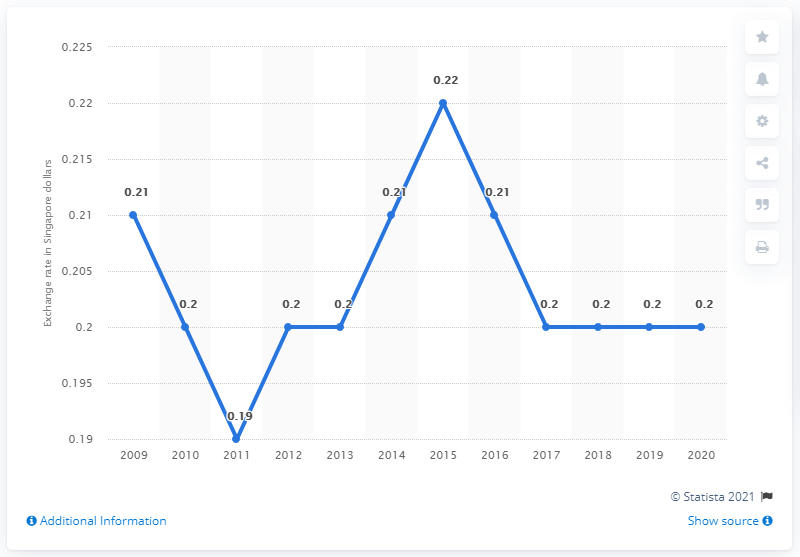Give some essential details in this illustration. In 2020, the average exchange rate from Singapore dollar to Chinese renminbi was 0.2... 